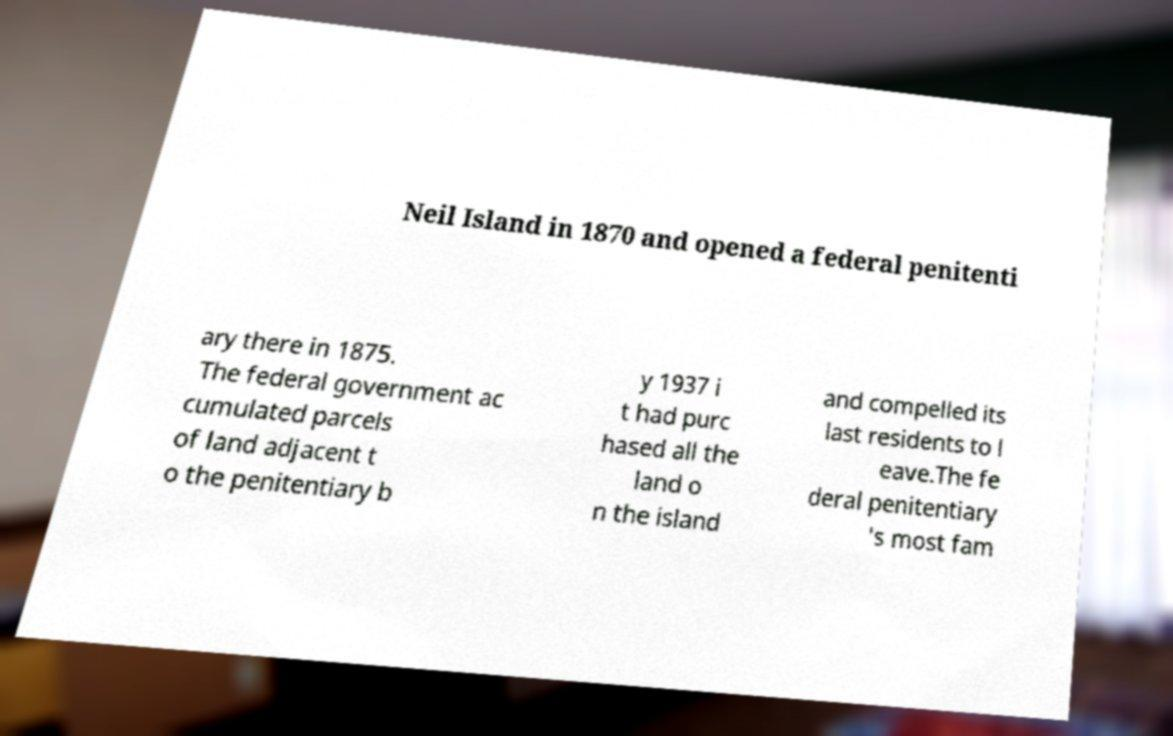Could you extract and type out the text from this image? Neil Island in 1870 and opened a federal penitenti ary there in 1875. The federal government ac cumulated parcels of land adjacent t o the penitentiary b y 1937 i t had purc hased all the land o n the island and compelled its last residents to l eave.The fe deral penitentiary 's most fam 